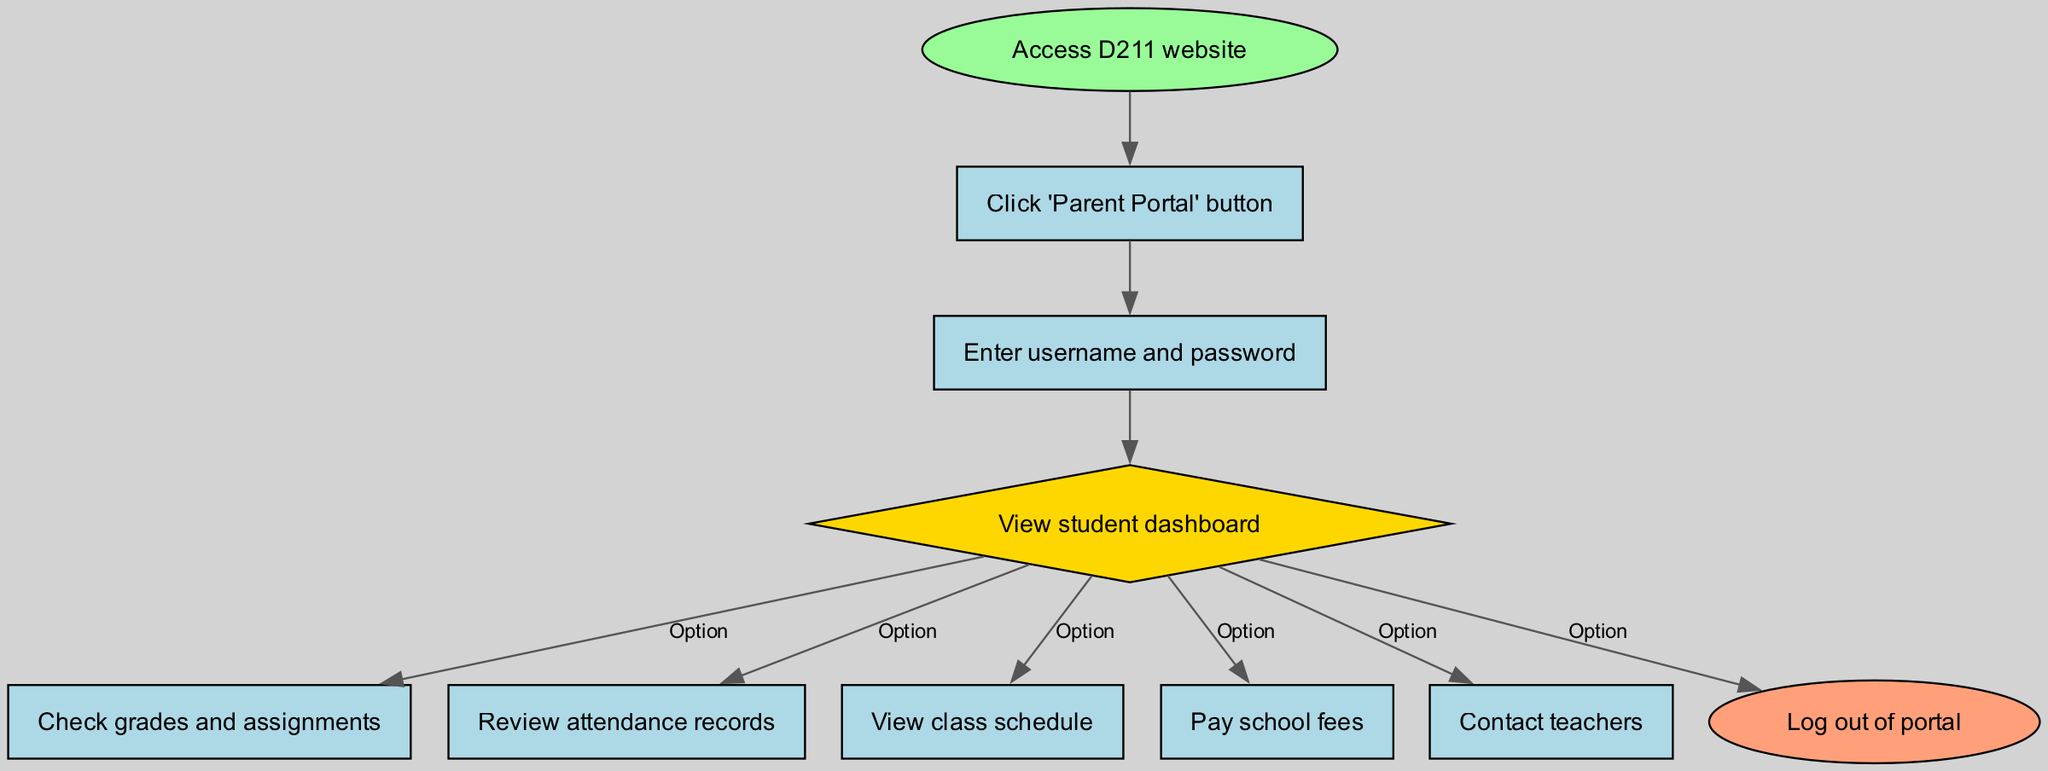What is the first step to navigate the parent portal? The diagram indicates that the first step is to "Access D211 website." This is represented as the starting point (node) of the flow.
Answer: Access D211 website What do you see after entering your credentials? After entering the username and password, the next step is to "View student dashboard," which indicates that you will have access to your student's information.
Answer: View student dashboard How many options are available from the dashboard? The diagram shows five options branching from the "View student dashboard" node, indicating the different actions available to take next.
Answer: Five What is the last action before logging out? The diagram reveals that after viewing the options on the dashboard, one must select an action to take before logging out, which is represented by the "Log out of portal" node as the final step.
Answer: Log out of portal What is the action to view your child's attendance records? From the "View student dashboard," the action to take is to "Review attendance records," as one of the options available after accessing the dashboard.
Answer: Review attendance records Identify the shape used for the dashboard. In the diagram, the "View student dashboard" node is represented as a diamond shape, illustrating that it branches out to several other options.
Answer: Diamond What must you do before you can access the dashboard? According to the flow, you need to "Enter username and password" after clicking the Parent Portal button and before you can view the dashboard.
Answer: Enter username and password Which option allows you to contact your child's teachers? From the "View student dashboard," you have the option to "Contact teachers," highlighting communication as a function available through the portal.
Answer: Contact teachers What colors are associated with different node types in the diagram? The starting point (Access D211 website) is light green, the logout action is light coral, the dashboard is yellow, while all other actions are light blue. This coloring helps differentiate types of nodes in the diagram.
Answer: Light green, light coral, yellow, light blue 